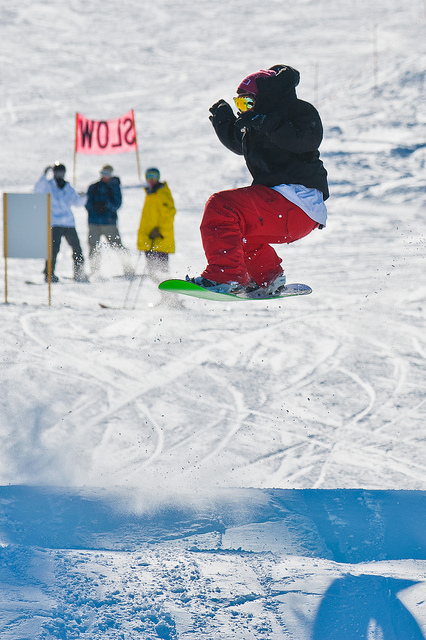Identify the text contained in this image. SLOW 